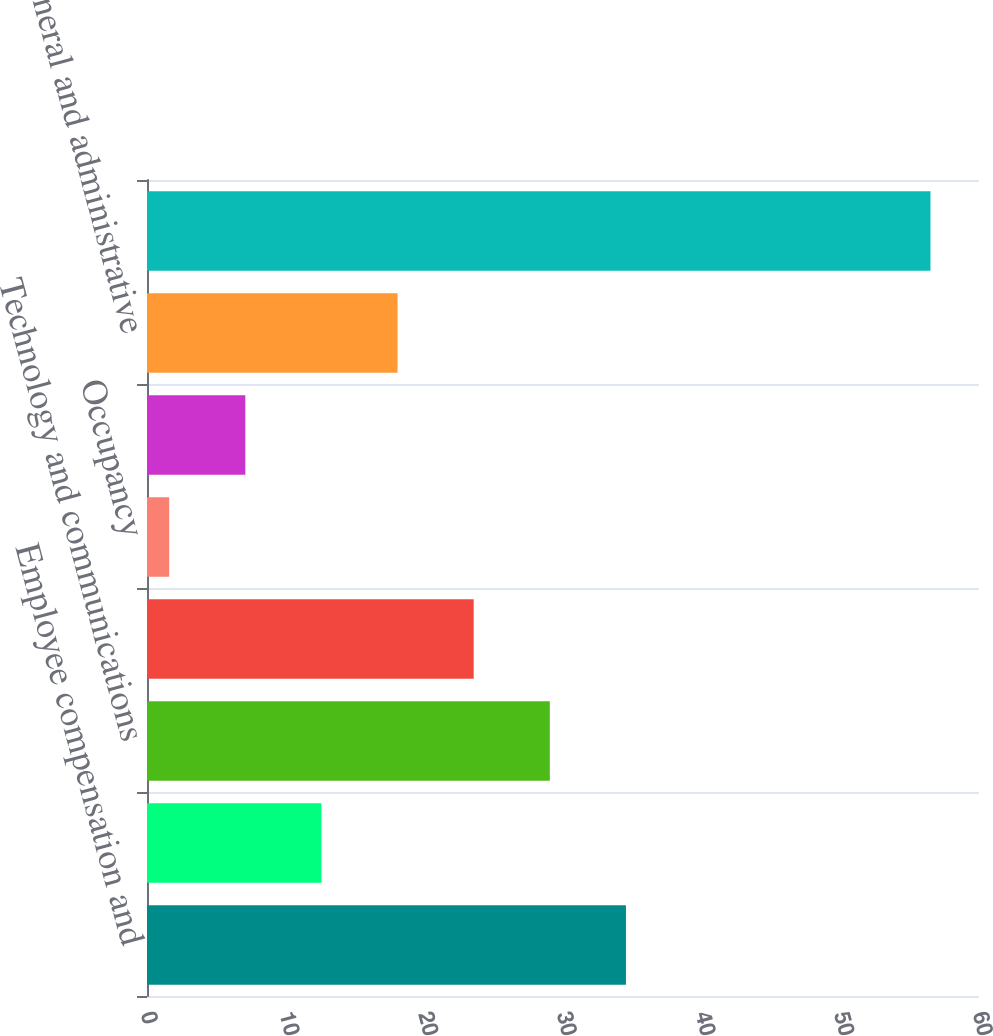Convert chart. <chart><loc_0><loc_0><loc_500><loc_500><bar_chart><fcel>Employee compensation and<fcel>Depreciation and amortization<fcel>Technology and communications<fcel>Professional and consulting<fcel>Occupancy<fcel>Marketing and advertising<fcel>General and administrative<fcel>Total expenses<nl><fcel>34.54<fcel>12.58<fcel>29.05<fcel>23.56<fcel>1.6<fcel>7.09<fcel>18.07<fcel>56.5<nl></chart> 